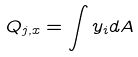Convert formula to latex. <formula><loc_0><loc_0><loc_500><loc_500>Q _ { j , x } = \int y _ { i } d A</formula> 